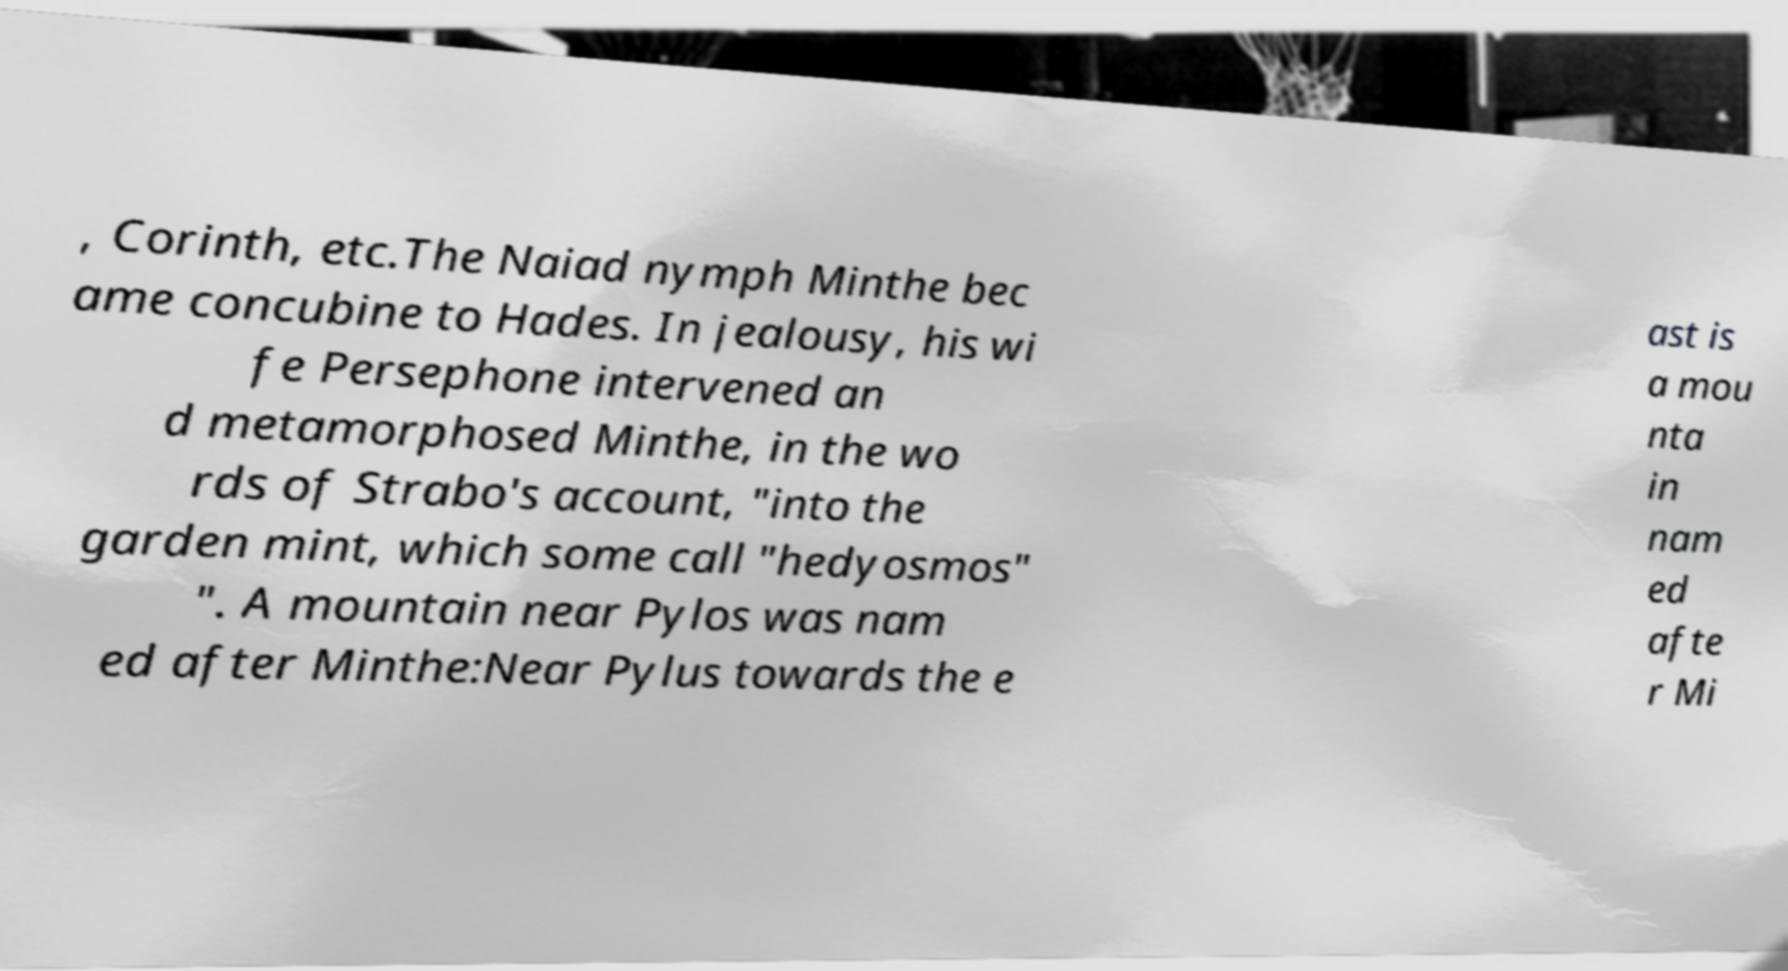Could you extract and type out the text from this image? , Corinth, etc.The Naiad nymph Minthe bec ame concubine to Hades. In jealousy, his wi fe Persephone intervened an d metamorphosed Minthe, in the wo rds of Strabo's account, "into the garden mint, which some call "hedyosmos" ". A mountain near Pylos was nam ed after Minthe:Near Pylus towards the e ast is a mou nta in nam ed afte r Mi 